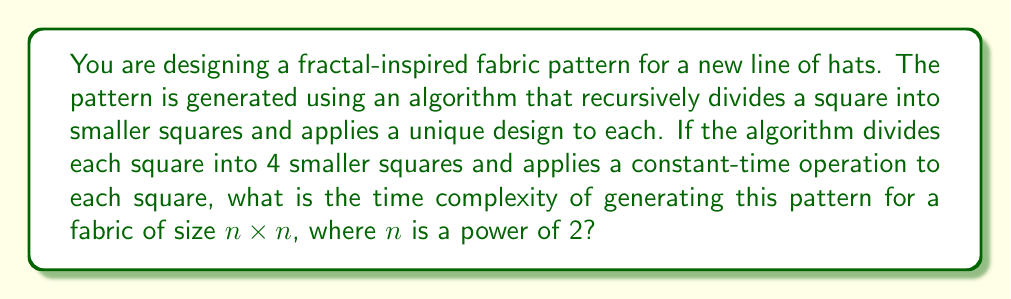What is the answer to this math problem? Let's analyze this problem step by step:

1) First, we need to understand the recursion pattern:
   - We start with one large square (the entire fabric)
   - At each step, we divide each square into 4 smaller squares
   - We apply a constant-time operation to each square

2) Let's define $T(n)$ as the time complexity for a square of size $n \times n$:

   $T(n) = 4T(n/2) + c$

   Where $c$ is the constant time for the operation applied to each square.

3) This recurrence relation follows the pattern of the Master Theorem:

   $T(n) = aT(n/b) + f(n)$

   Where $a = 4$, $b = 2$, and $f(n) = c$

4) To apply the Master Theorem, we compare $n^{\log_b a}$ with $f(n)$:

   $n^{\log_b a} = n^{\log_2 4} = n^2$

5) Since $f(n) = c$ is $O(n^2)$, we're in case 2 of the Master Theorem:

   If $f(n) = \Theta(n^{\log_b a})$, then $T(n) = \Theta(n^{\log_b a} \log n)$

6) Therefore, $T(n) = \Theta(n^2 \log n)$

This means the time complexity grows slightly faster than quadratic, but not quite cubic.
Answer: The time complexity of the algorithm is $\Theta(n^2 \log n)$. 